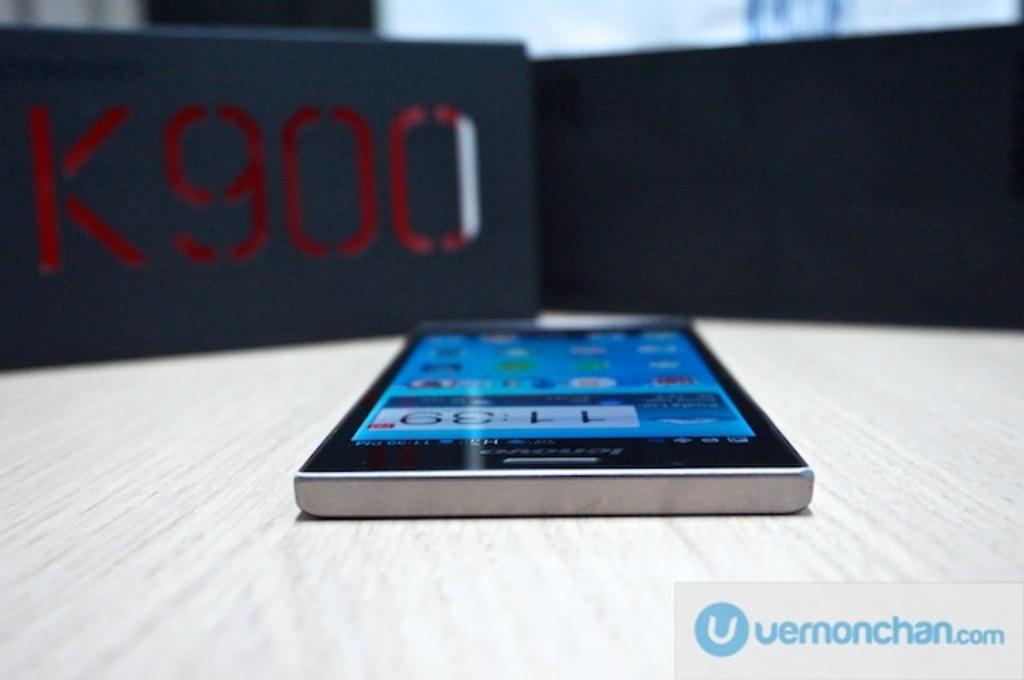What model phone is shown?
Provide a succinct answer. K900. What number is mentioned above the phone?
Make the answer very short. 900. 